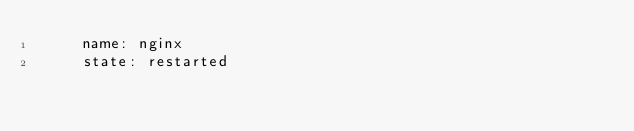Convert code to text. <code><loc_0><loc_0><loc_500><loc_500><_YAML_>     name: nginx
     state: restarted
</code> 